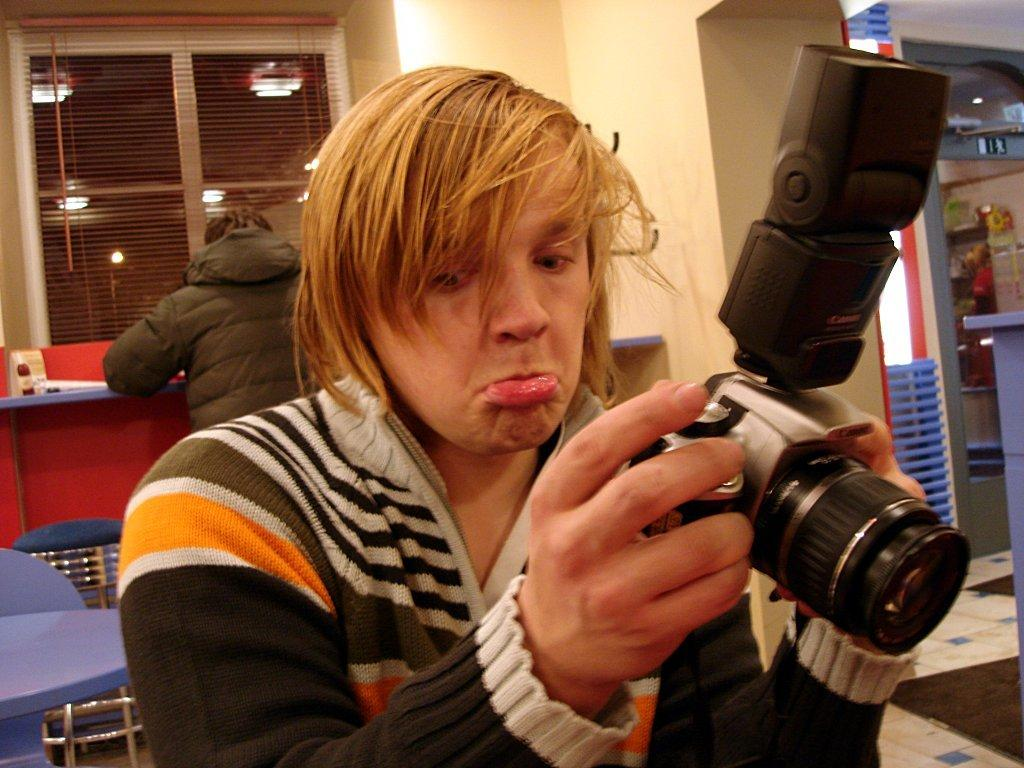What is the person in the foreground of the image holding? The person is holding a camera in the image. Can you describe the person in the background of the image? There is another person in the background of the image, but no specific details are provided. What can be seen through the window in the background of the image? The facts do not mention what can be seen through the window. What furniture is present in the background of the image? There is a chair and a table in the background of the image. What type of mitten is the person wearing in the image? There is no mention of a mitten or any clothing in the image. What trick is the person performing with the camera in the image? There is no indication of a trick being performed with the camera in the image. 